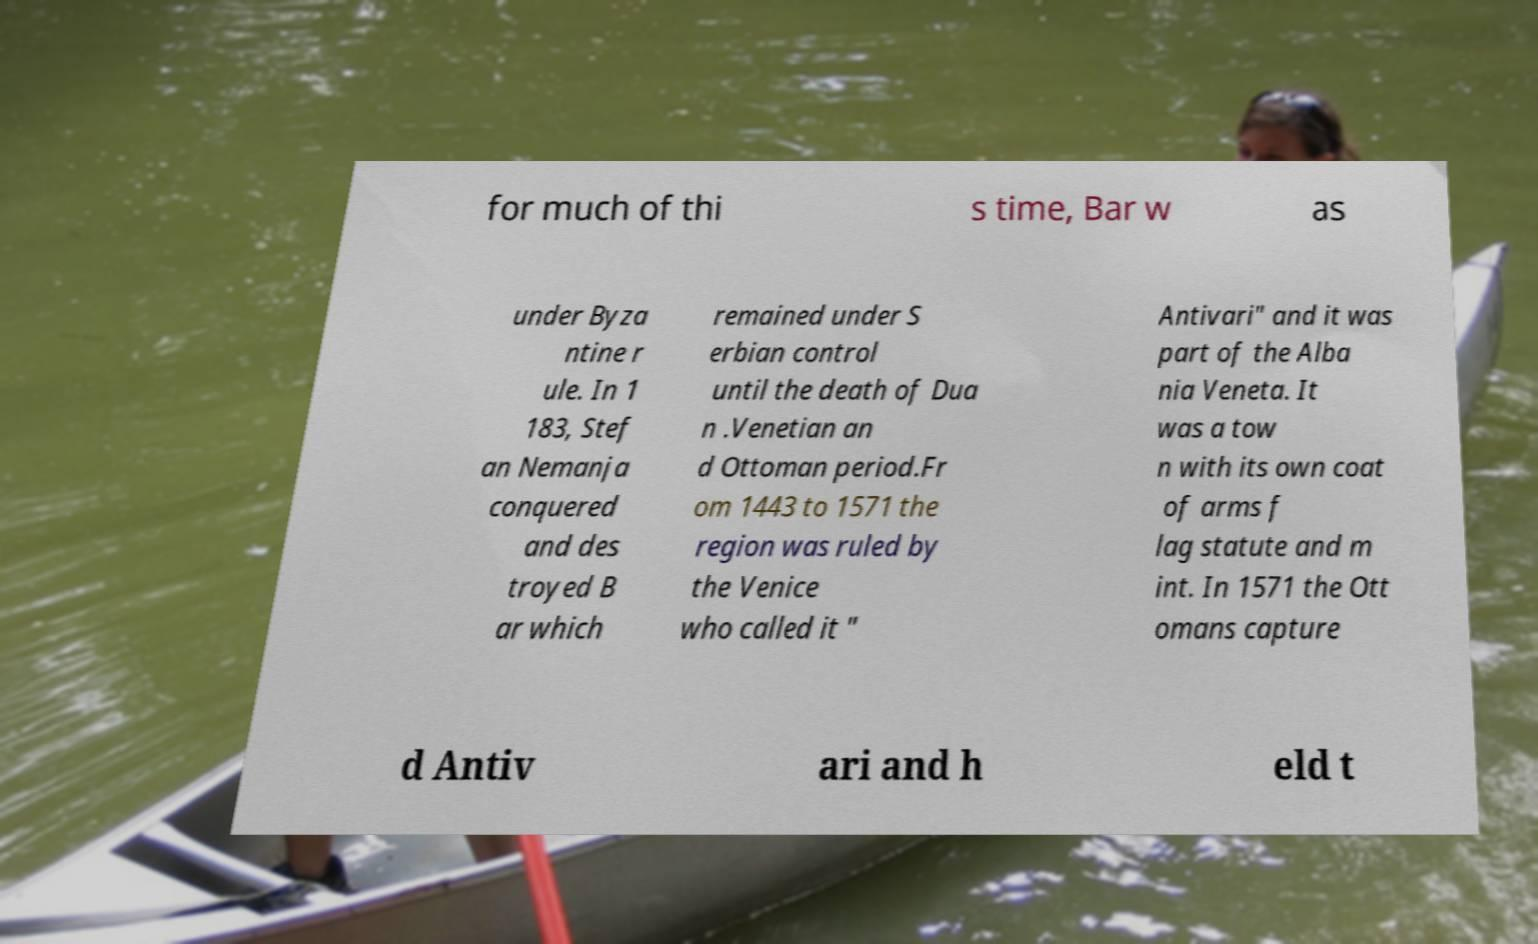For documentation purposes, I need the text within this image transcribed. Could you provide that? for much of thi s time, Bar w as under Byza ntine r ule. In 1 183, Stef an Nemanja conquered and des troyed B ar which remained under S erbian control until the death of Dua n .Venetian an d Ottoman period.Fr om 1443 to 1571 the region was ruled by the Venice who called it " Antivari" and it was part of the Alba nia Veneta. It was a tow n with its own coat of arms f lag statute and m int. In 1571 the Ott omans capture d Antiv ari and h eld t 